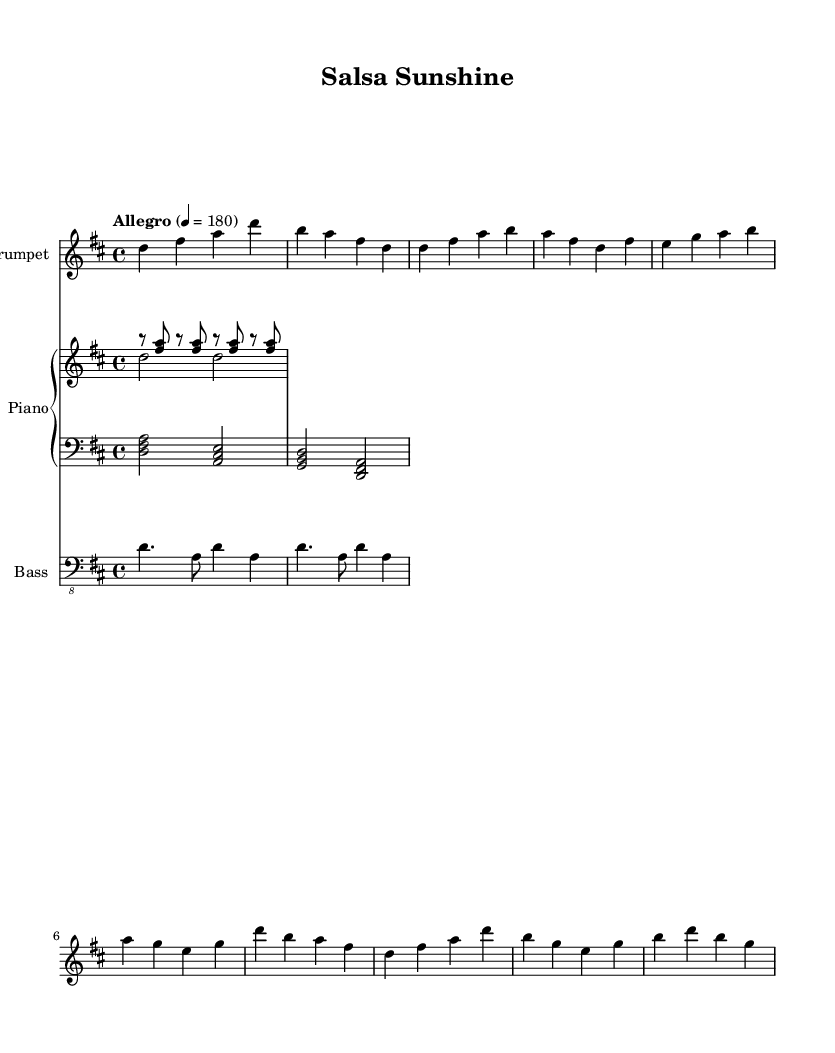What is the key signature of this music? The key signature is D major, indicated by the presence of two sharps (F# and C#).
Answer: D major What is the time signature of this music? The time signature is 4/4, which means there are four beats in each measure. This can be found at the beginning of the sheet music.
Answer: 4/4 What is the tempo marking for this piece? The tempo marking is "Allegro," which indicates that the piece should be played at a fast and lively pace. The specific tempo is also provided as 4 = 180.
Answer: Allegro How many measures are in the trumpet part? There are a total of 8 measures in the trumpet part, as defined by the vertical lines separating each measure in the sheet music.
Answer: 8 What kind of rhythm pattern does the piano right hand play? The piano right hand plays a simplified montuno pattern, which consists of repeated eighth note figures alternating with rests.
Answer: Montuno What is the bass line pattern referred to in Latin music? The bass line follows a simplified tumbao pattern, where the notes are played in a syncopated rhythm that is characteristic of salsa music.
Answer: Tumbao What is the main chord progression in the piano left hand? The main chord progression in the piano left hand consists of D, A, G, and back to D, creating a cyclical structure common in salsa.
Answer: D, A, G 